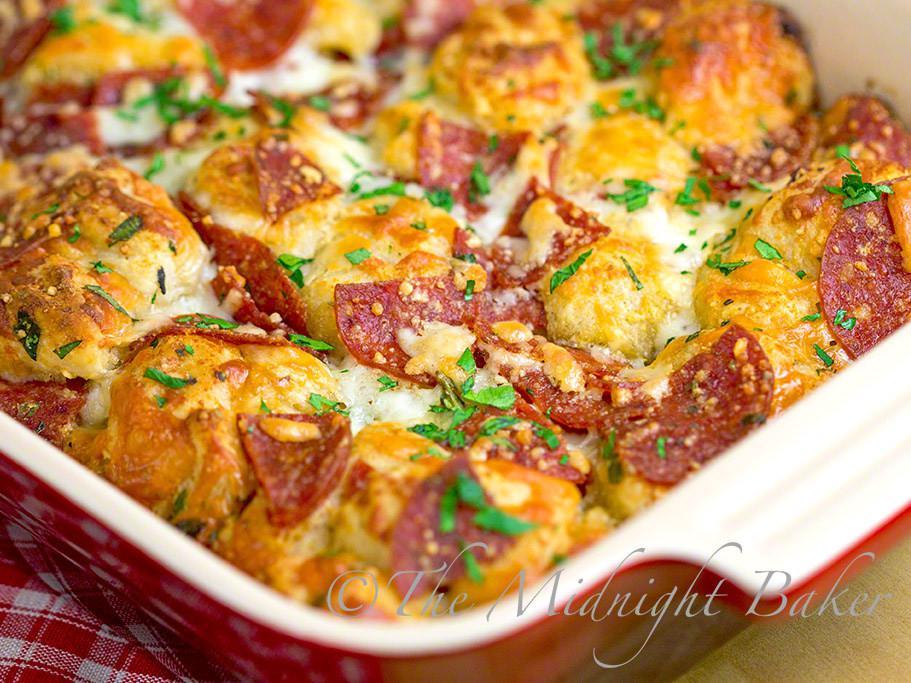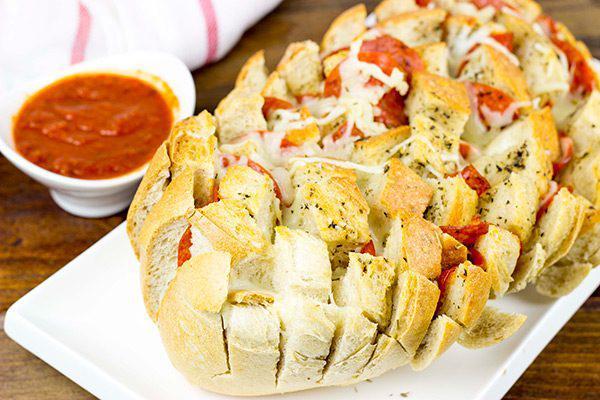The first image is the image on the left, the second image is the image on the right. Given the left and right images, does the statement "The right image shows an oblong loaf with pepperoni sticking out of criss-cross cuts, and the left image includes at least one rectangular shape with pepperonis and melted cheese on top." hold true? Answer yes or no. Yes. 